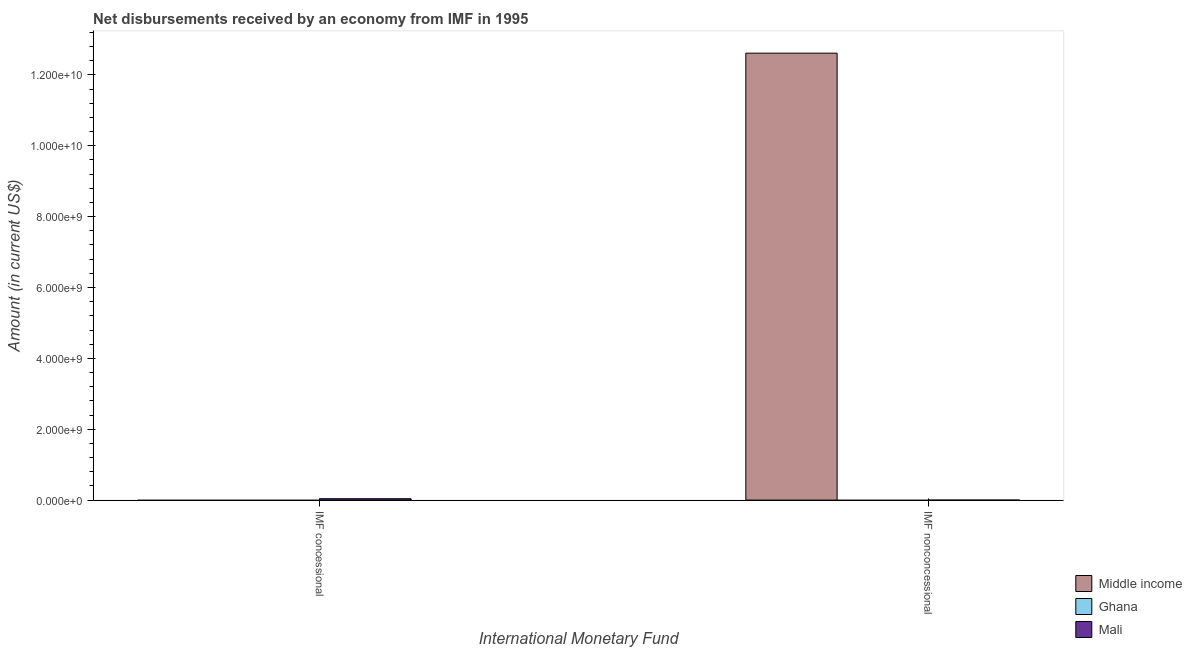How many different coloured bars are there?
Give a very brief answer. 2. Are the number of bars per tick equal to the number of legend labels?
Provide a succinct answer. No. How many bars are there on the 1st tick from the right?
Ensure brevity in your answer.  1. What is the label of the 2nd group of bars from the left?
Your answer should be compact. IMF nonconcessional. What is the net non concessional disbursements from imf in Ghana?
Your answer should be compact. 0. Across all countries, what is the maximum net non concessional disbursements from imf?
Your answer should be compact. 1.26e+1. In which country was the net concessional disbursements from imf maximum?
Offer a terse response. Mali. What is the total net non concessional disbursements from imf in the graph?
Give a very brief answer. 1.26e+1. What is the difference between the net non concessional disbursements from imf in Middle income and the net concessional disbursements from imf in Ghana?
Provide a succinct answer. 1.26e+1. What is the average net concessional disbursements from imf per country?
Keep it short and to the point. 1.31e+07. In how many countries, is the net non concessional disbursements from imf greater than 2000000000 US$?
Your response must be concise. 1. In how many countries, is the net non concessional disbursements from imf greater than the average net non concessional disbursements from imf taken over all countries?
Provide a succinct answer. 1. How many countries are there in the graph?
Offer a terse response. 3. Where does the legend appear in the graph?
Your answer should be very brief. Bottom right. How many legend labels are there?
Provide a succinct answer. 3. What is the title of the graph?
Provide a succinct answer. Net disbursements received by an economy from IMF in 1995. What is the label or title of the X-axis?
Ensure brevity in your answer.  International Monetary Fund. What is the Amount (in current US$) of Middle income in IMF concessional?
Provide a short and direct response. 0. What is the Amount (in current US$) in Ghana in IMF concessional?
Keep it short and to the point. 0. What is the Amount (in current US$) in Mali in IMF concessional?
Provide a succinct answer. 3.93e+07. What is the Amount (in current US$) of Middle income in IMF nonconcessional?
Make the answer very short. 1.26e+1. What is the Amount (in current US$) in Mali in IMF nonconcessional?
Offer a very short reply. 0. Across all International Monetary Fund, what is the maximum Amount (in current US$) of Middle income?
Your answer should be very brief. 1.26e+1. Across all International Monetary Fund, what is the maximum Amount (in current US$) in Mali?
Offer a very short reply. 3.93e+07. Across all International Monetary Fund, what is the minimum Amount (in current US$) in Middle income?
Offer a very short reply. 0. What is the total Amount (in current US$) of Middle income in the graph?
Ensure brevity in your answer.  1.26e+1. What is the total Amount (in current US$) of Mali in the graph?
Your answer should be very brief. 3.93e+07. What is the average Amount (in current US$) of Middle income per International Monetary Fund?
Give a very brief answer. 6.31e+09. What is the average Amount (in current US$) in Mali per International Monetary Fund?
Your answer should be compact. 1.96e+07. What is the difference between the highest and the lowest Amount (in current US$) in Middle income?
Keep it short and to the point. 1.26e+1. What is the difference between the highest and the lowest Amount (in current US$) of Mali?
Make the answer very short. 3.93e+07. 